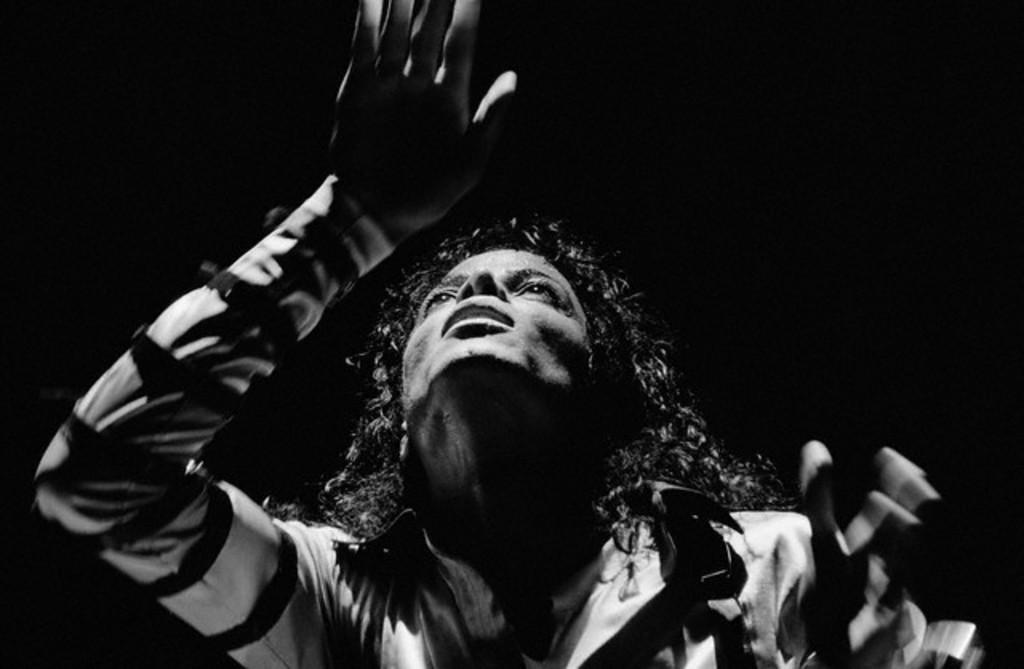What is the color scheme of the image? The image is black and white. Can you describe the main subject in the image? There is a man in the image. Are there any boats visible in the image? No, there are no boats present in the image. Can you see a river in the background of the image? No, there is no river visible in the image. 